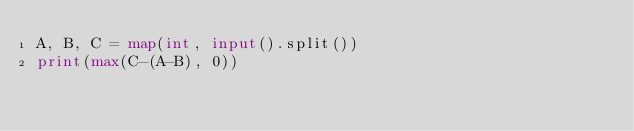<code> <loc_0><loc_0><loc_500><loc_500><_Python_>A, B, C = map(int, input().split())
print(max(C-(A-B), 0))</code> 